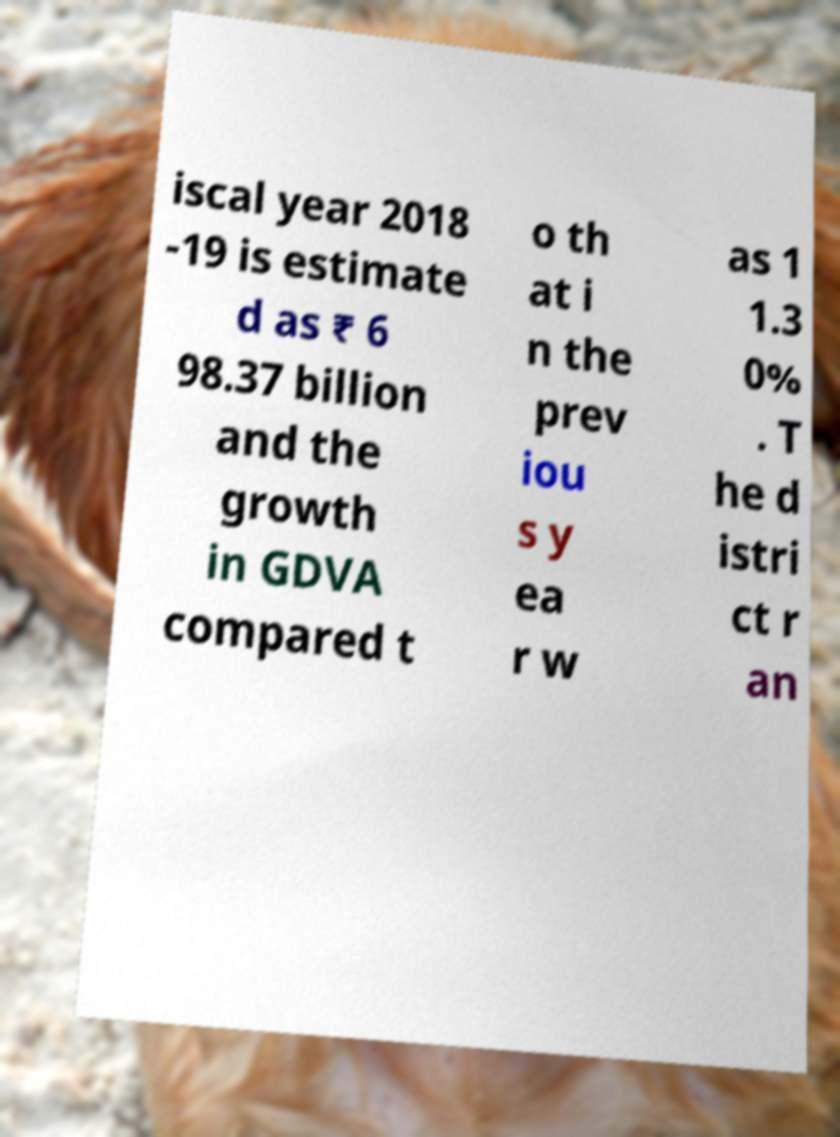Please read and relay the text visible in this image. What does it say? iscal year 2018 -19 is estimate d as ₹ 6 98.37 billion and the growth in GDVA compared t o th at i n the prev iou s y ea r w as 1 1.3 0% . T he d istri ct r an 